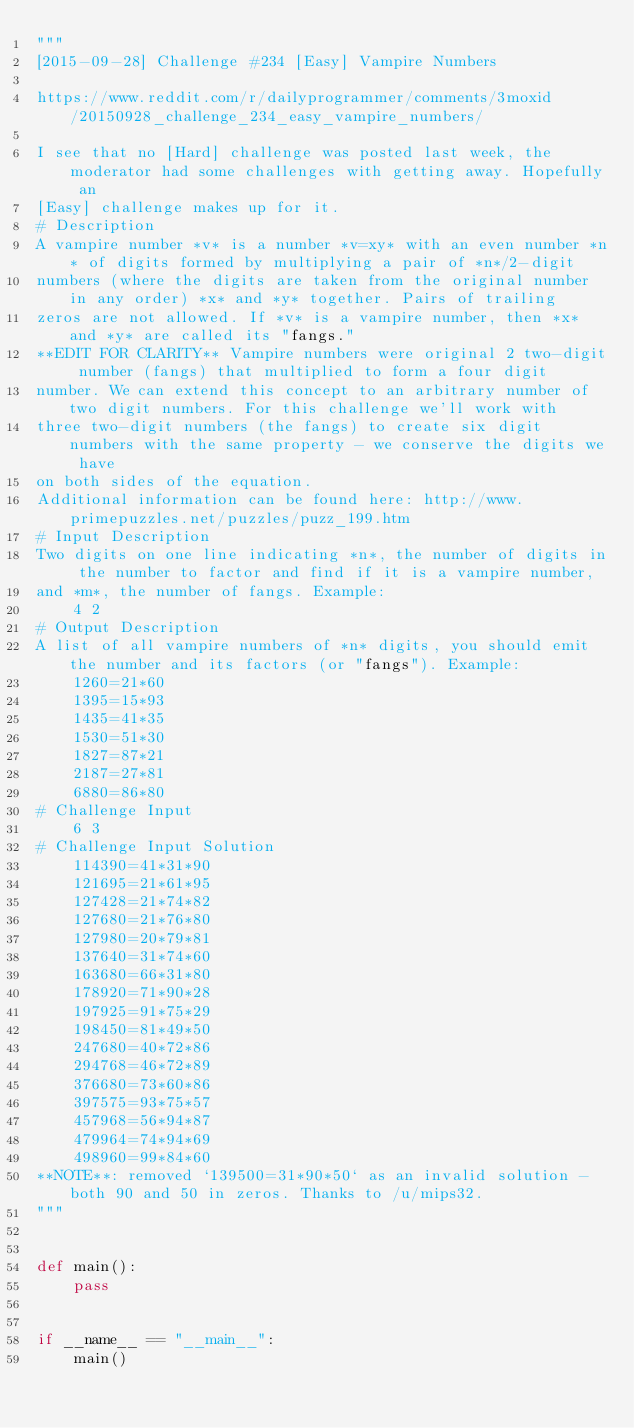<code> <loc_0><loc_0><loc_500><loc_500><_Python_>"""
[2015-09-28] Challenge #234 [Easy] Vampire Numbers

https://www.reddit.com/r/dailyprogrammer/comments/3moxid/20150928_challenge_234_easy_vampire_numbers/

I see that no [Hard] challenge was posted last week, the moderator had some challenges with getting away. Hopefully an
[Easy] challenge makes up for it. 
# Description
A vampire number *v* is a number *v=xy* with an even number *n* of digits formed by multiplying a pair of *n*/2-digit
numbers (where the digits are taken from the original number in any order) *x* and *y* together. Pairs of trailing
zeros are not allowed. If *v* is a vampire number, then *x* and *y* are called its "fangs." 
**EDIT FOR CLARITY** Vampire numbers were original 2 two-digit number (fangs) that multiplied to form a four digit
number. We can extend this concept to an arbitrary number of two digit numbers. For this challenge we'll work with
three two-digit numbers (the fangs) to create six digit numbers with the same property - we conserve the digits we have
on both sides of the equation.
Additional information can be found here: http://www.primepuzzles.net/puzzles/puzz_199.htm
# Input Description
Two digits on one line indicating *n*, the number of digits in the number to factor and find if it is a vampire number,
and *m*, the number of fangs. Example:
    4 2
# Output Description
A list of all vampire numbers of *n* digits, you should emit the number and its factors (or "fangs"). Example:
    1260=21*60
    1395=15*93
    1435=41*35
    1530=51*30
    1827=87*21
    2187=27*81
    6880=86*80
# Challenge Input
    6 3
# Challenge Input Solution 
    114390=41*31*90
    121695=21*61*95
    127428=21*74*82
    127680=21*76*80
    127980=20*79*81
    137640=31*74*60
    163680=66*31*80
    178920=71*90*28
    197925=91*75*29
    198450=81*49*50
    247680=40*72*86
    294768=46*72*89
    376680=73*60*86
    397575=93*75*57
    457968=56*94*87
    479964=74*94*69
    498960=99*84*60
**NOTE**: removed `139500=31*90*50` as an invalid solution - both 90 and 50 in zeros. Thanks to /u/mips32. 
"""


def main():
    pass


if __name__ == "__main__":
    main()
</code> 